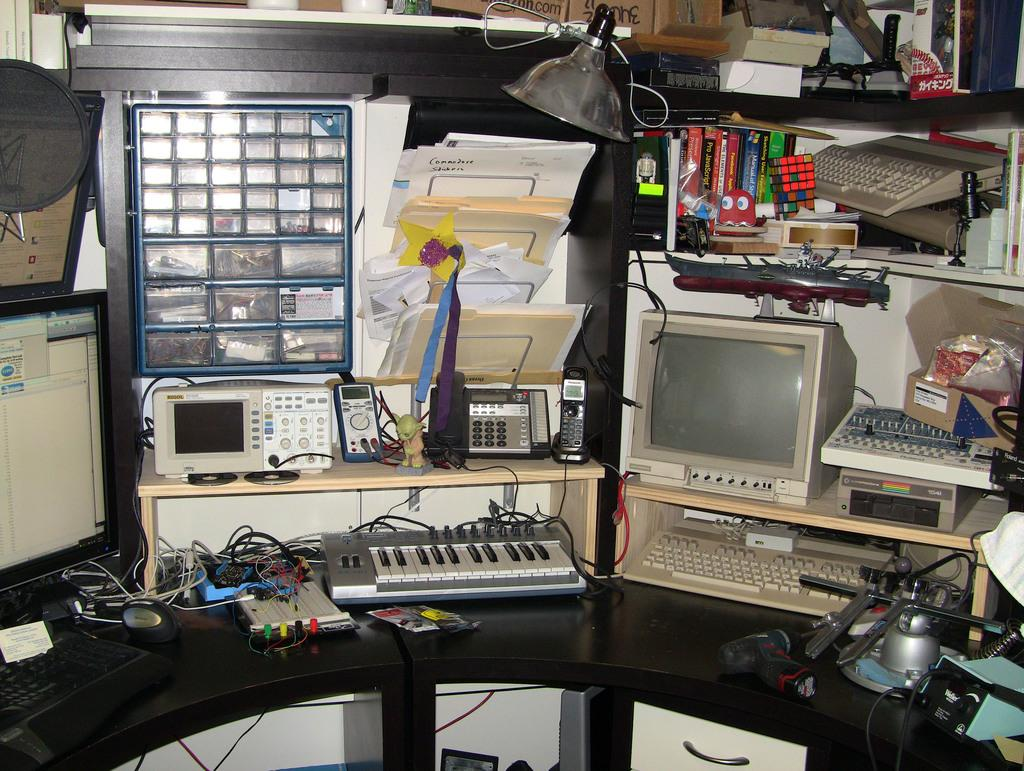What type of musical instrument is on the table in the image? There is a piano board on the table in the image. What other electronic devices are on the table? A monitor, a keyboard, and a light are on the table. What can be used for communication in the image? There is a landline phone on the table. What type of paperwork is present on the table? Papers are on the table. How many grapes are on the table in the image? There are no grapes present in the image. What type of star can be seen shining through the window in the image? There is no window or star visible in the image. 